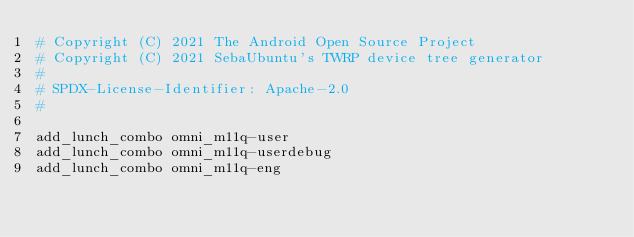<code> <loc_0><loc_0><loc_500><loc_500><_Bash_># Copyright (C) 2021 The Android Open Source Project
# Copyright (C) 2021 SebaUbuntu's TWRP device tree generator
#
# SPDX-License-Identifier: Apache-2.0
#

add_lunch_combo omni_m11q-user
add_lunch_combo omni_m11q-userdebug
add_lunch_combo omni_m11q-eng
</code> 